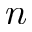<formula> <loc_0><loc_0><loc_500><loc_500>n</formula> 